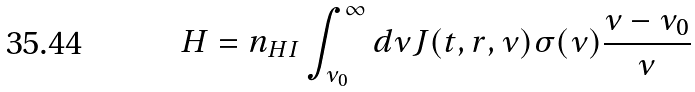<formula> <loc_0><loc_0><loc_500><loc_500>H = n _ { H I } \int _ { \nu _ { 0 } } ^ { \infty } d \nu J ( t , r , \nu ) \sigma ( \nu ) \frac { \nu - \nu _ { 0 } } { \nu }</formula> 